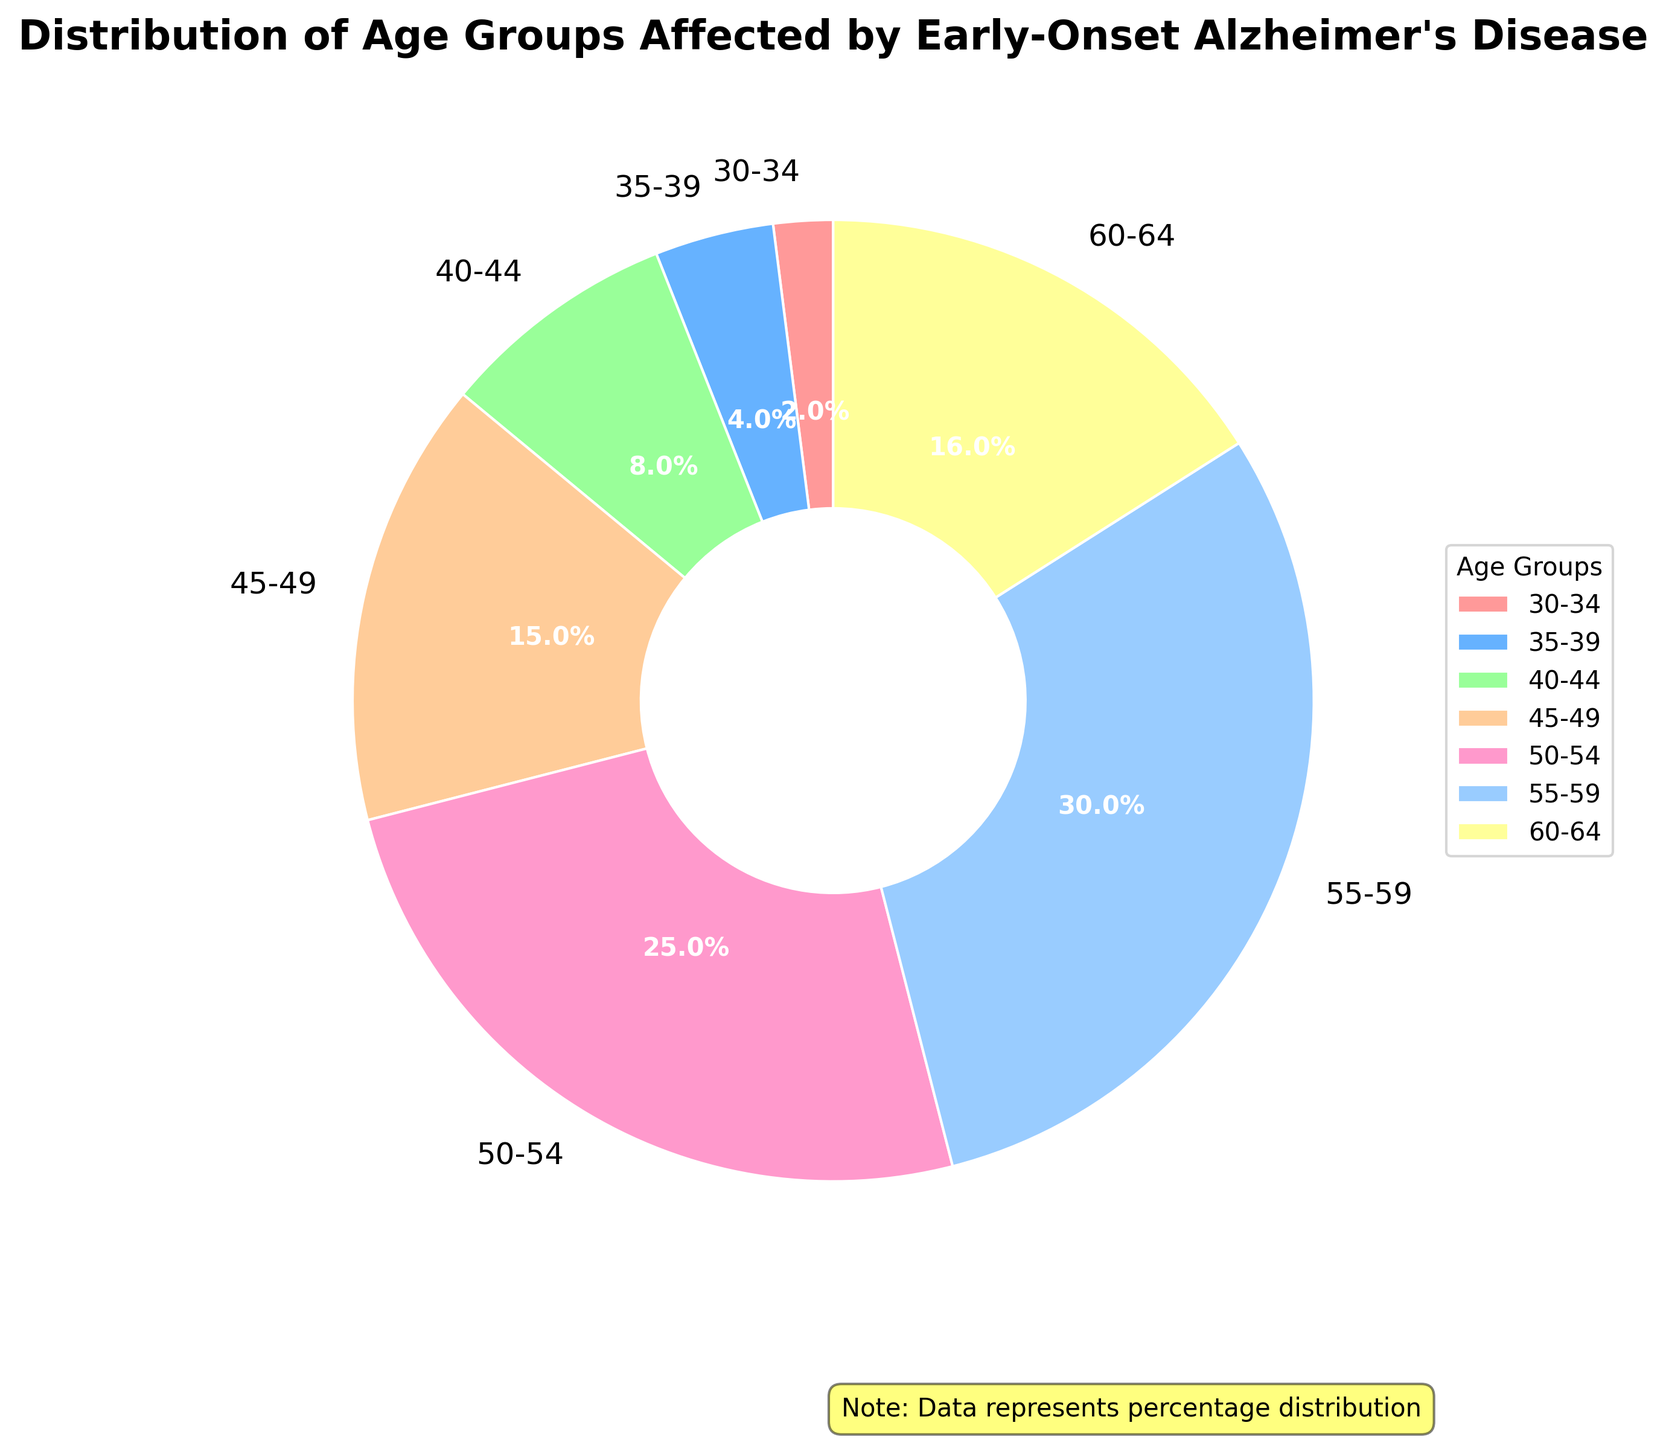What age group has the highest percentage of early-onset Alzheimer's cases? The pie chart shows the segment with a percentage label of 30%, which is the largest slice in the chart, and it corresponds to the age group 55-59.
Answer: 55-59 Which two age groups combined account for more than 50% of the cases? By examining the percentages, the largest slices are 55-59 (30%) and 50-54 (25%). Adding these two percentages together: 30% + 25% = 55%, which is more than 50%.
Answer: 55-59 and 50-54 Which age group has the smallest percentage? The pie chart shows the smallest slice with a label of 2%, corresponding to the age group 30-34.
Answer: 30-34 What is the total percentage of cases for people below age 50? We need to sum the percentages for the age groups 30-34, 35-39, 40-44, and 45-49. The sum is 2% + 4% + 8% + 15% = 29%.
Answer: 29% How does the percentage of cases for the 60-64 age group compare to the 40-44 age group? The percentages are 16% for the 60-64 age group and 8% for the 40-44 age group. Comparatively, 16% is twice as large as 8%.
Answer: 60-64 has twice the percentage What age group has a percentage closest to 20%? The pie chart doesn't have a segment exactly 20%, but the age group 50-54 has a percentage closest to it at 25%.
Answer: 50-54 What's the difference in percentage between the 45-49 and 35-39 age groups? The 45-49 age group has 15% and the 35-39 age group has 4%. The difference is 15% - 4% = 11%.
Answer: 11% Which color represents the age group with the second lowest percentage? The pie chart shows the 35-39 age group with a percentage of 4%, the second lowest. This group is colored blue.
Answer: Blue What age group lies between the second and third most affected groups in terms of percentage? The second most affected group is 50-54 with 25% and the third is 60-64 with 16%. The next highest, falling between these two, is the 45-49 group with 15%.
Answer: 45-49 Identify the three age groups that together make up approximately 60% of the cases. Adding percentages for 55-59 (30%), 50-54 (25%), and 45-49 (15%) sums up to 70%, which slightly surpasses 60%. While splitting exact 60% isn't possible, this is the closest grouping.
Answer: 55-59, 50-54, and 45-49 